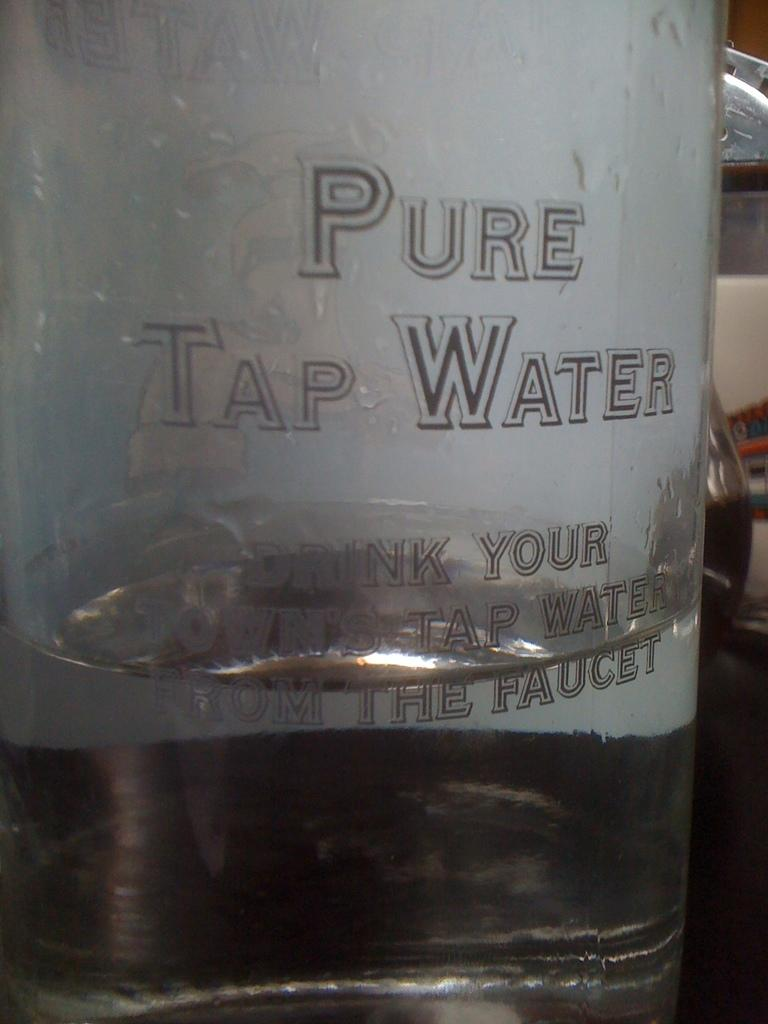<image>
Write a terse but informative summary of the picture. A bottle of Pure tap water sitting on a shelf. 